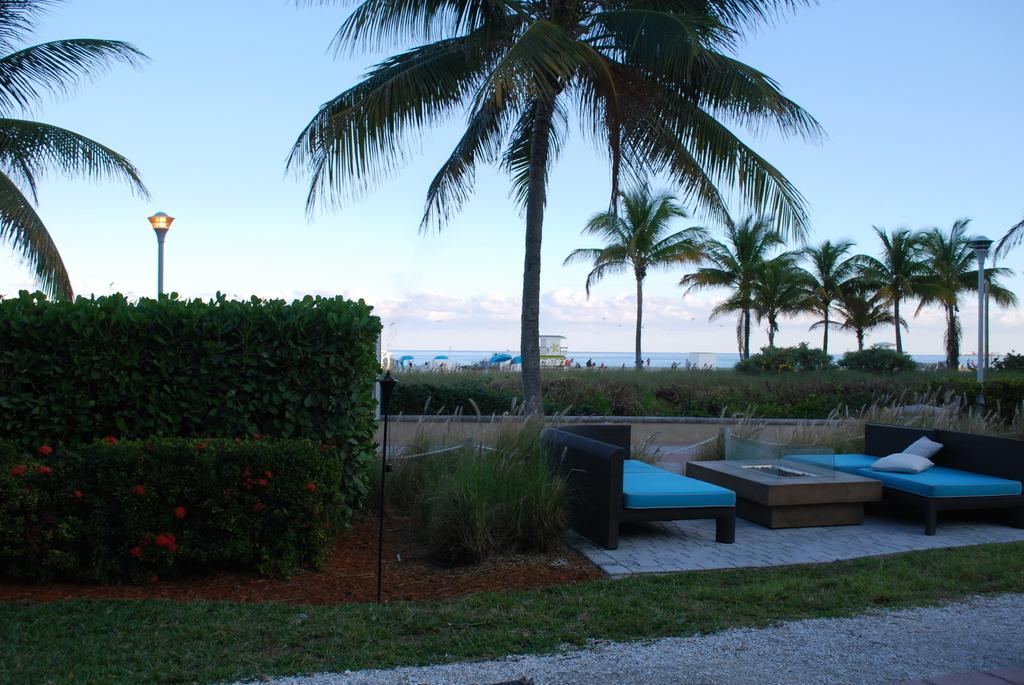What is the weather like in the image? The sky in the image is cloudy, indicating a potentially overcast or cloudy day. What type of vegetation can be seen in the image? There are trees and grass on the side in the image. What type of furniture is present in the image? There is a sofa on the ground in the image. What is the source of light in the image? There is light in the image, which could be natural sunlight or artificial lighting. What type of veil is draped over the hill in the image? There is no hill or veil present in the image. 